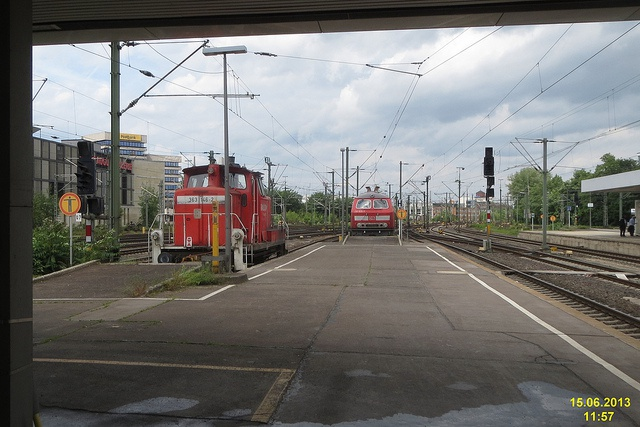Describe the objects in this image and their specific colors. I can see train in black, darkgray, brown, and gray tones, traffic light in black, gray, and darkgray tones, traffic light in black, gray, darkgray, and lightgray tones, traffic light in black tones, and people in black and gray tones in this image. 